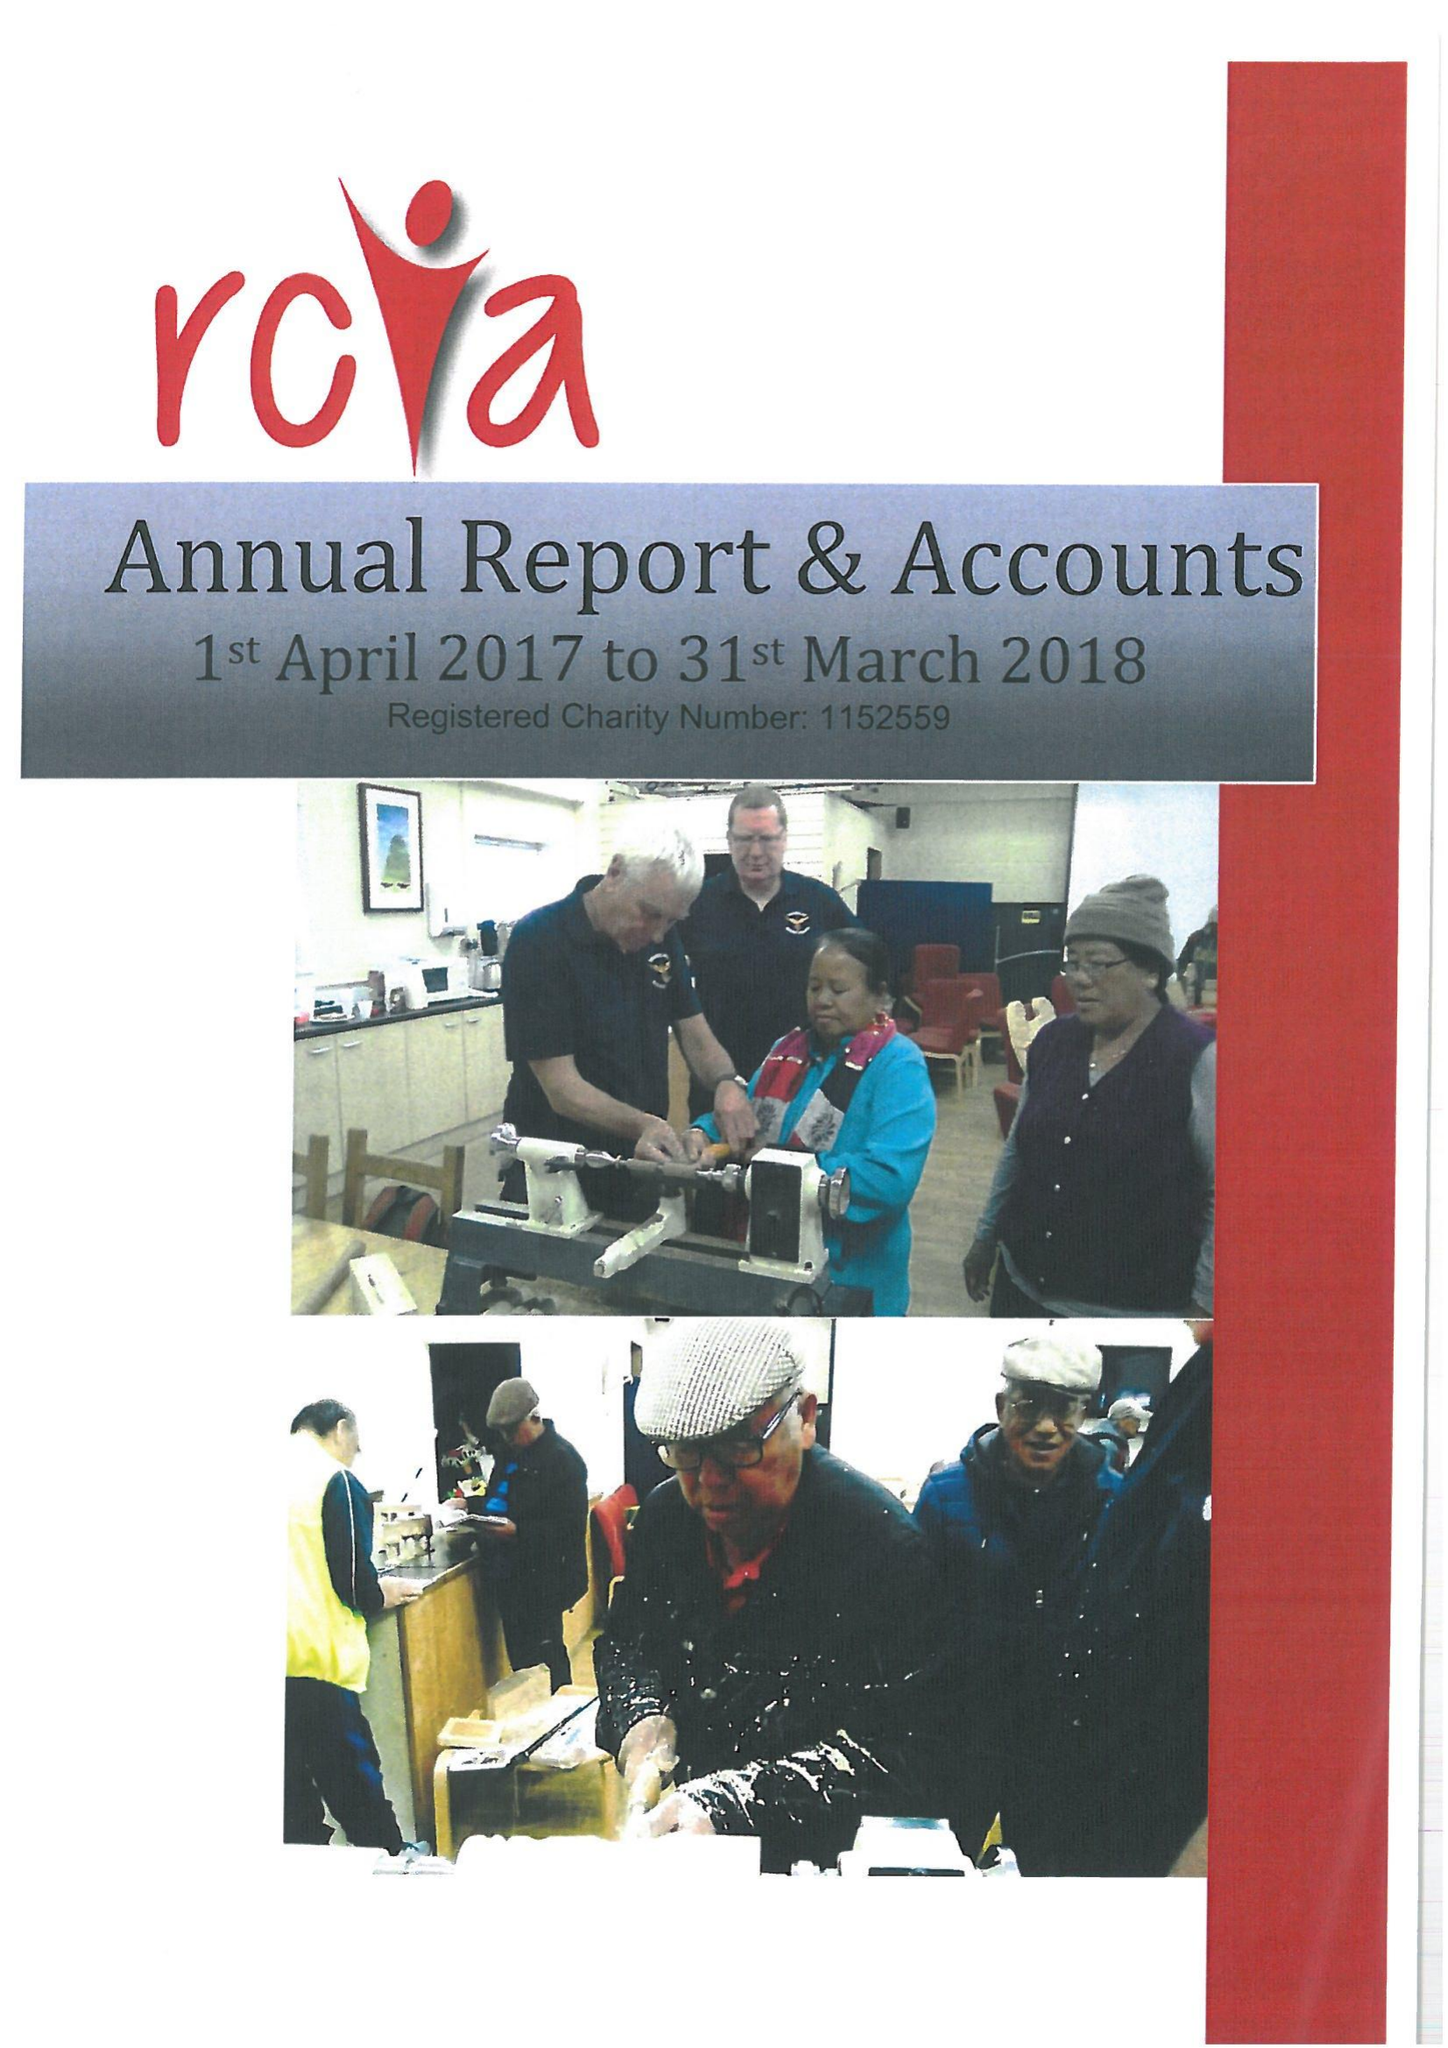What is the value for the address__postcode?
Answer the question using a single word or phrase. DL9 4AF 